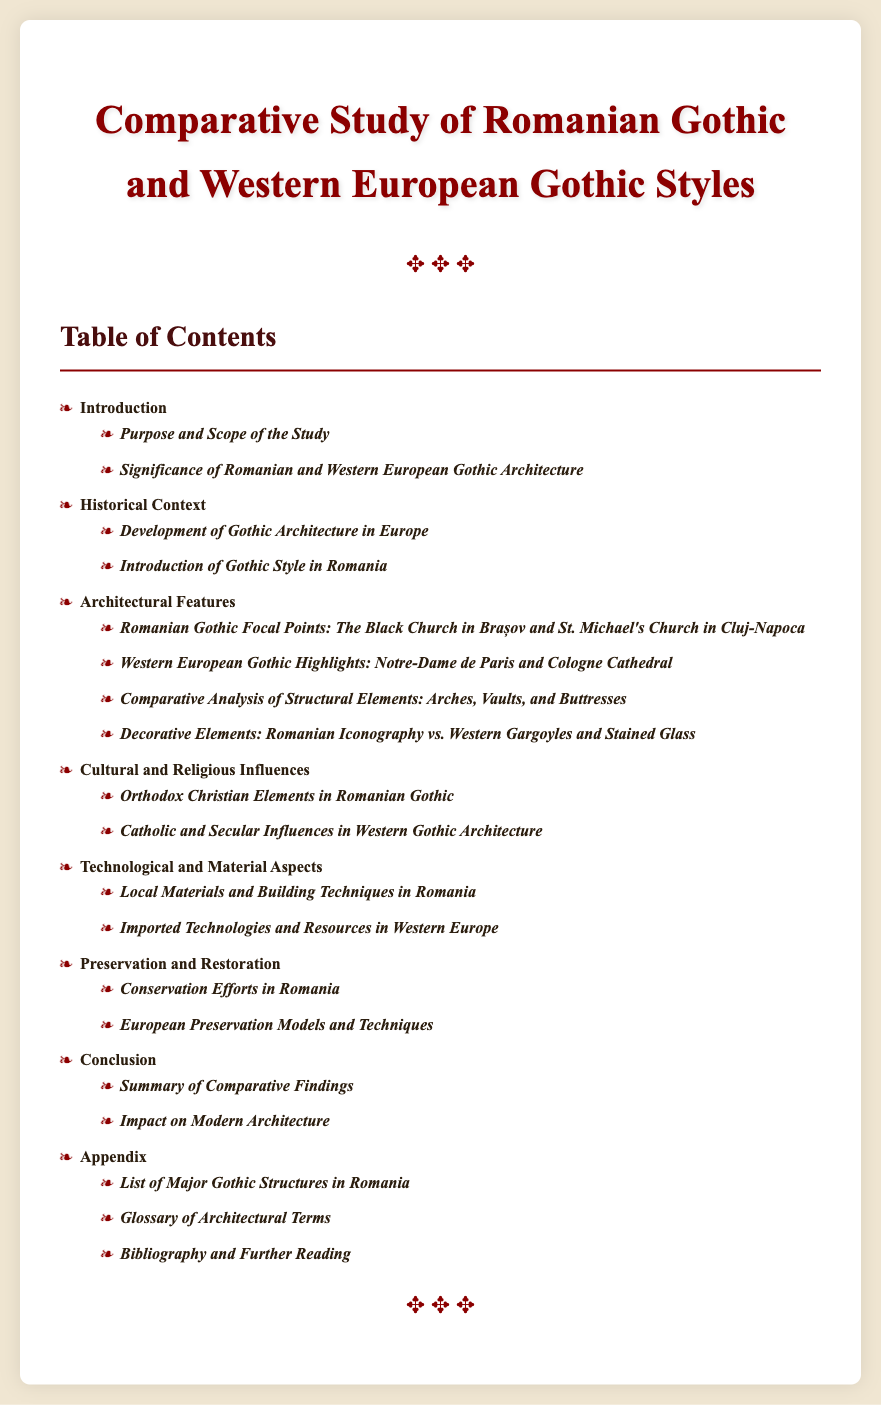What is the title of the document? The title of the document is prominently displayed at the top and summarizes the main focus.
Answer: Comparative Study of Romanian Gothic and Western European Gothic Styles How many chapters are listed in the Table of Contents? The number of chapters can be counted from the document's outline provided in the Table of Contents.
Answer: Seven What is the first section of the Introduction chapter? The first section under the Introduction chapter is the first bullet point.
Answer: Purpose and Scope of the Study Which Gothic structure is highlighted in Romania? The document specifies two notable Romanian Gothic structures, one of them is mentioned in an architectural feature section.
Answer: The Black Church in Brașov What influence is observed in Western Gothic architecture? The document notes several influences in Western Gothic architecture including religious and secular aspects, specifically mentioned under cultural influences.
Answer: Catholic and Secular Influences What is discussed in the Preservation and Restoration chapter? The chapter is divided into conservation efforts and comparison of models, indicating its focus area.
Answer: Conservation Efforts in Romania Which architectural term section is included in the Appendix? The Appendix provides additional informative content related to architecture, including terms.
Answer: Glossary of Architectural Terms 